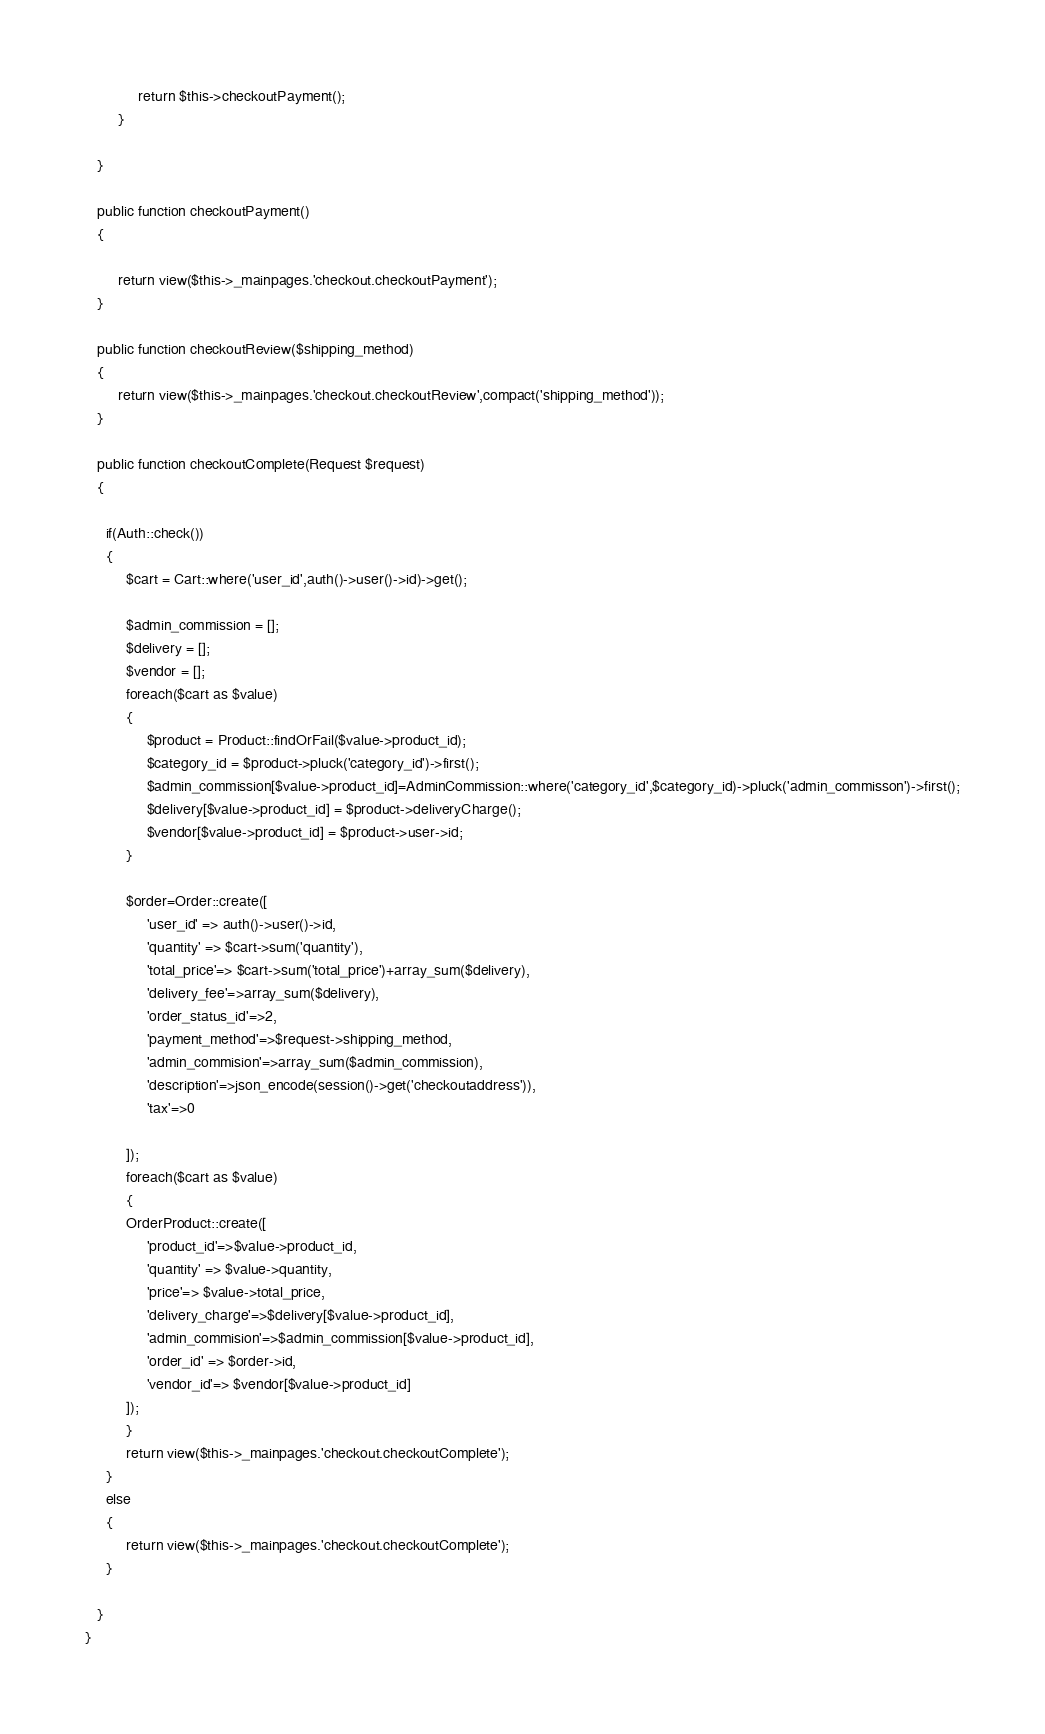<code> <loc_0><loc_0><loc_500><loc_500><_PHP_>             return $this->checkoutPayment();
        }

   }

   public function checkoutPayment()
   {

        return view($this->_mainpages.'checkout.checkoutPayment');
   }

   public function checkoutReview($shipping_method)
   {
        return view($this->_mainpages.'checkout.checkoutReview',compact('shipping_method'));
   }

   public function checkoutComplete(Request $request)
   {
     
     if(Auth::check())
     {
          $cart = Cart::where('user_id',auth()->user()->id)->get();
          
          $admin_commission = [];
          $delivery = [];
          $vendor = [];
          foreach($cart as $value)
          {
               $product = Product::findOrFail($value->product_id);
               $category_id = $product->pluck('category_id')->first();
               $admin_commission[$value->product_id]=AdminCommission::where('category_id',$category_id)->pluck('admin_commisson')->first();
               $delivery[$value->product_id] = $product->deliveryCharge();
               $vendor[$value->product_id] = $product->user->id;
          }
          
          $order=Order::create([
               'user_id' => auth()->user()->id,
               'quantity' => $cart->sum('quantity'),
               'total_price'=> $cart->sum('total_price')+array_sum($delivery),
               'delivery_fee'=>array_sum($delivery),
               'order_status_id'=>2,
               'payment_method'=>$request->shipping_method,
               'admin_commision'=>array_sum($admin_commission),
               'description'=>json_encode(session()->get('checkoutaddress')),
               'tax'=>0

          ]);
          foreach($cart as $value)
          {
          OrderProduct::create([
               'product_id'=>$value->product_id,
               'quantity' => $value->quantity,
               'price'=> $value->total_price,
               'delivery_charge'=>$delivery[$value->product_id],
               'admin_commision'=>$admin_commission[$value->product_id],
               'order_id' => $order->id,
               'vendor_id'=> $vendor[$value->product_id]
          ]);
          }
          return view($this->_mainpages.'checkout.checkoutComplete');
     }
     else
     {
          return view($this->_mainpages.'checkout.checkoutComplete');
     }
      
   }
}
</code> 